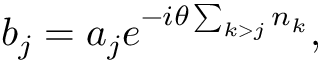Convert formula to latex. <formula><loc_0><loc_0><loc_500><loc_500>{ b } _ { j } = { a } _ { j } e ^ { - i \theta \sum _ { k > j } { n } _ { k } } ,</formula> 